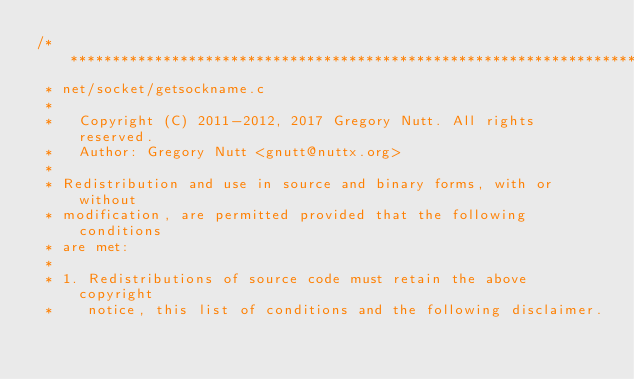<code> <loc_0><loc_0><loc_500><loc_500><_C_>/****************************************************************************
 * net/socket/getsockname.c
 *
 *   Copyright (C) 2011-2012, 2017 Gregory Nutt. All rights reserved.
 *   Author: Gregory Nutt <gnutt@nuttx.org>
 *
 * Redistribution and use in source and binary forms, with or without
 * modification, are permitted provided that the following conditions
 * are met:
 *
 * 1. Redistributions of source code must retain the above copyright
 *    notice, this list of conditions and the following disclaimer.</code> 